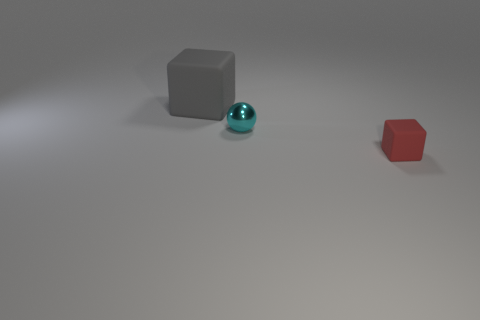Add 1 big gray cubes. How many objects exist? 4 Subtract all balls. How many objects are left? 2 Subtract all gray metallic blocks. Subtract all blocks. How many objects are left? 1 Add 2 cubes. How many cubes are left? 4 Add 2 large yellow cubes. How many large yellow cubes exist? 2 Subtract 0 cyan blocks. How many objects are left? 3 